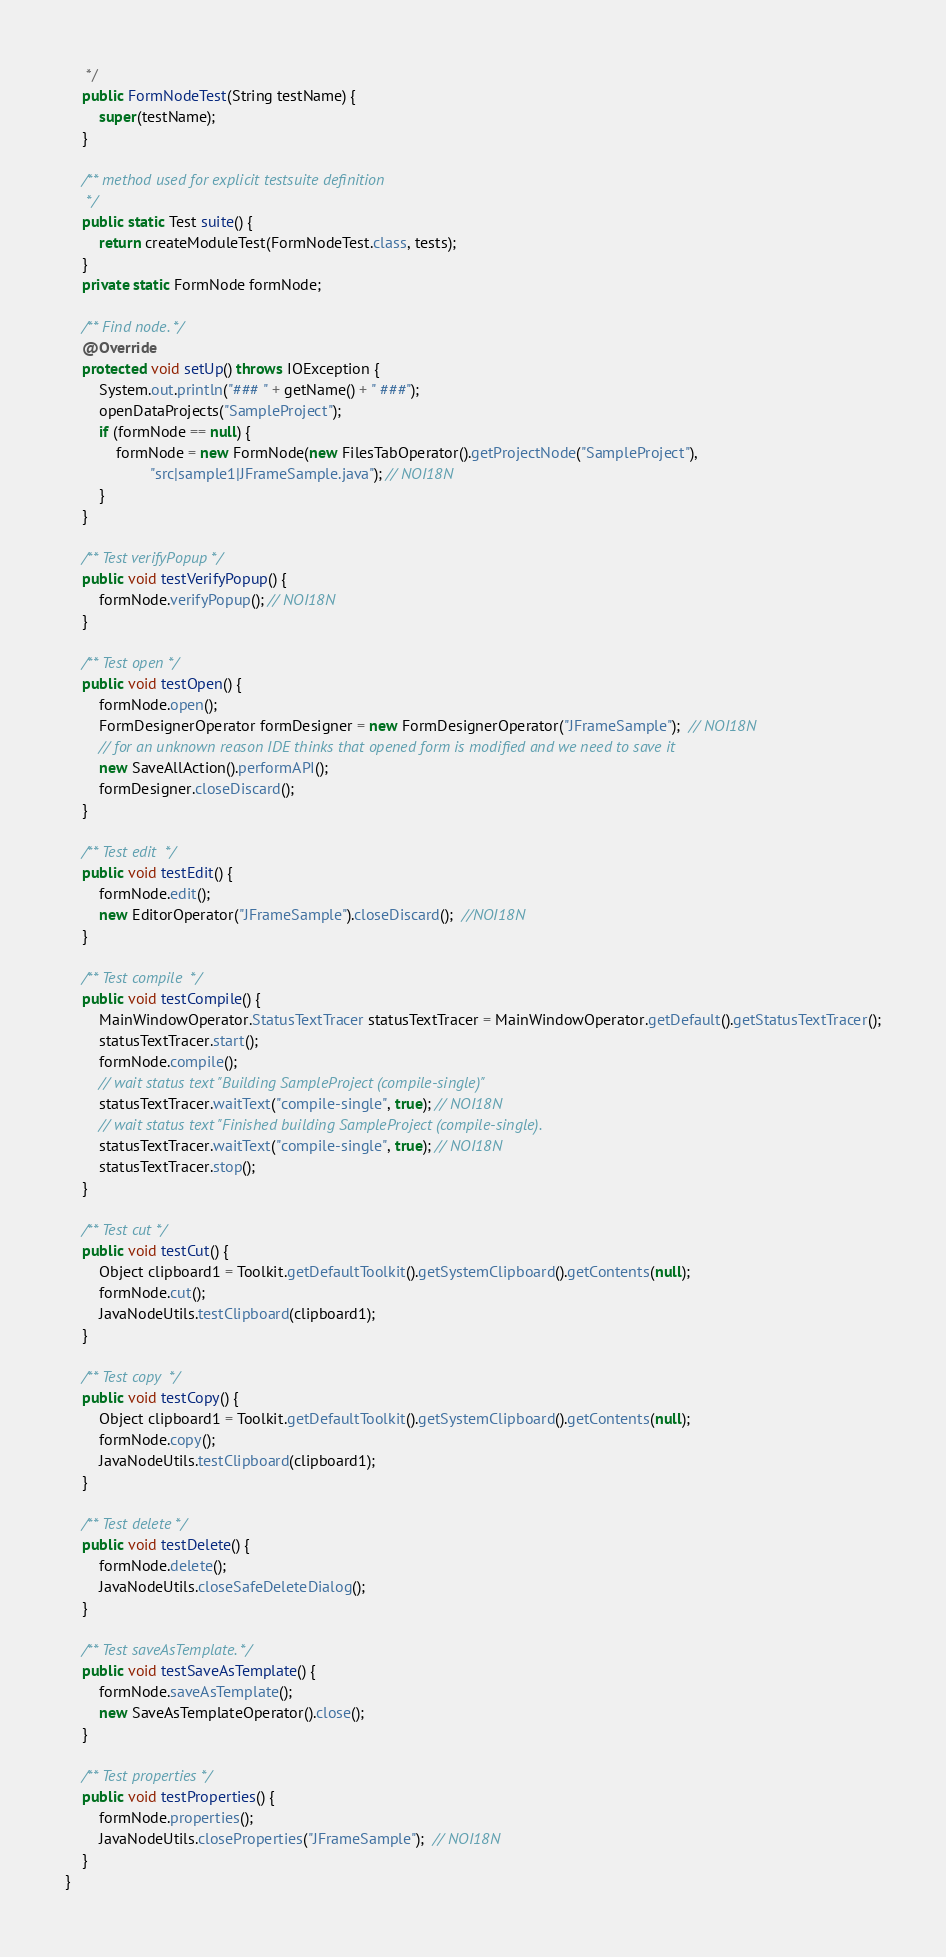Convert code to text. <code><loc_0><loc_0><loc_500><loc_500><_Java_>     */
    public FormNodeTest(String testName) {
        super(testName);
    }

    /** method used for explicit testsuite definition
     */
    public static Test suite() {
        return createModuleTest(FormNodeTest.class, tests);
    }
    private static FormNode formNode;

    /** Find node. */
    @Override
    protected void setUp() throws IOException {
        System.out.println("### " + getName() + " ###");
        openDataProjects("SampleProject");
        if (formNode == null) {
            formNode = new FormNode(new FilesTabOperator().getProjectNode("SampleProject"),
                    "src|sample1|JFrameSample.java"); // NOI18N
        }
    }

    /** Test verifyPopup */
    public void testVerifyPopup() {
        formNode.verifyPopup(); // NOI18N
    }

    /** Test open */
    public void testOpen() {
        formNode.open();
        FormDesignerOperator formDesigner = new FormDesignerOperator("JFrameSample");  // NOI18N
        // for an unknown reason IDE thinks that opened form is modified and we need to save it
        new SaveAllAction().performAPI();
        formDesigner.closeDiscard();
    }

    /** Test edit  */
    public void testEdit() {
        formNode.edit();
        new EditorOperator("JFrameSample").closeDiscard();  //NOI18N
    }

    /** Test compile  */
    public void testCompile() {
        MainWindowOperator.StatusTextTracer statusTextTracer = MainWindowOperator.getDefault().getStatusTextTracer();
        statusTextTracer.start();
        formNode.compile();
        // wait status text "Building SampleProject (compile-single)"
        statusTextTracer.waitText("compile-single", true); // NOI18N
        // wait status text "Finished building SampleProject (compile-single).
        statusTextTracer.waitText("compile-single", true); // NOI18N
        statusTextTracer.stop();
    }

    /** Test cut */
    public void testCut() {
        Object clipboard1 = Toolkit.getDefaultToolkit().getSystemClipboard().getContents(null);
        formNode.cut();
        JavaNodeUtils.testClipboard(clipboard1);
    }

    /** Test copy  */
    public void testCopy() {
        Object clipboard1 = Toolkit.getDefaultToolkit().getSystemClipboard().getContents(null);
        formNode.copy();
        JavaNodeUtils.testClipboard(clipboard1);
    }

    /** Test delete */
    public void testDelete() {
        formNode.delete();
        JavaNodeUtils.closeSafeDeleteDialog();
    }

    /** Test saveAsTemplate. */
    public void testSaveAsTemplate() {
        formNode.saveAsTemplate();
        new SaveAsTemplateOperator().close();
    }

    /** Test properties */
    public void testProperties() {
        formNode.properties();
        JavaNodeUtils.closeProperties("JFrameSample");  // NOI18N
    }
}
</code> 